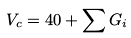<formula> <loc_0><loc_0><loc_500><loc_500>V _ { c } = 4 0 + \sum G _ { i }</formula> 